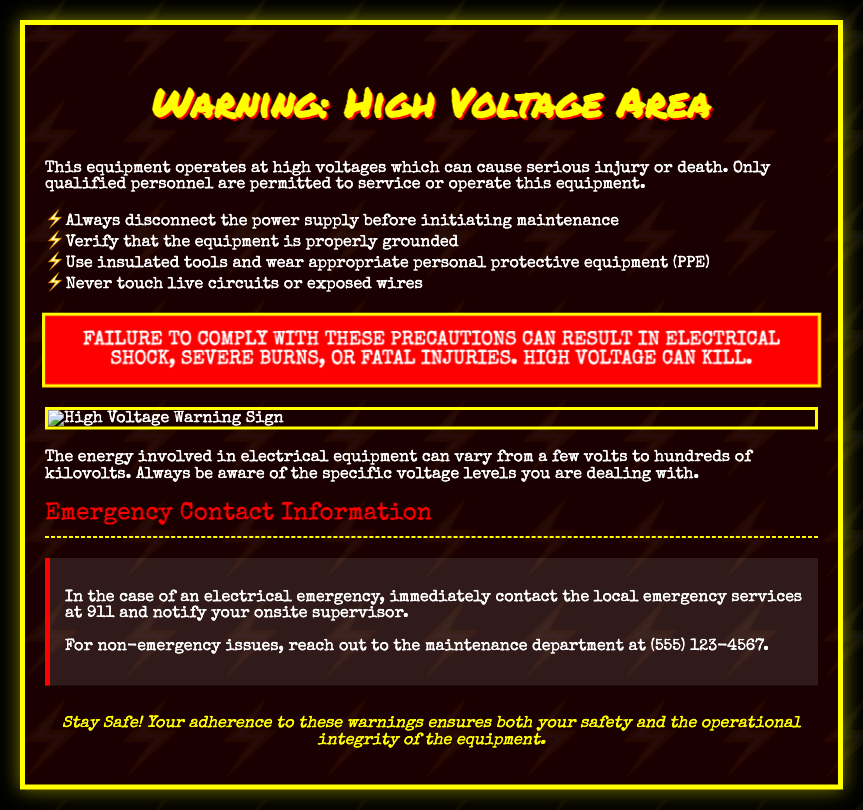What is the title of the document? The title of the document is displayed prominently at the top as "Warning: High Voltage Area."
Answer: Warning: High Voltage Area What color is the warning box? The warning box is red, as indicated in the document's styling and description.
Answer: Red What should you do before initiating maintenance? The document states you should "Always disconnect the power supply before initiating maintenance."
Answer: Disconnect the power supply How many emergency contact numbers are provided? The document provides two contact numbers: one for emergencies and one for non-emergency issues.
Answer: Two What type of personal protective equipment is recommended? The document mentions using "appropriate personal protective equipment (PPE)."
Answer: PPE What serious consequence is mentioned multiple times in the document? The document consistently warns about "electrical shock" as a severe consequence of not following the precautions.
Answer: Electrical shock What is the emergency services contact number? The document specifies that in case of an electrical emergency, you should contact local emergency services at "911."
Answer: 911 Why is it important to be aware of specific voltage levels? The document mentions that being aware of specific voltage levels is crucial due to variations "from a few volts to hundreds of kilovolts."
Answer: Safety What is a key phrase included in the warning box? The warning box contains the phrase "High Voltage can kill," emphasizing the dangers presented.
Answer: High Voltage can kill 